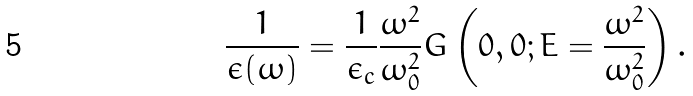Convert formula to latex. <formula><loc_0><loc_0><loc_500><loc_500>\frac { 1 } { \epsilon ( \omega ) } = \frac { 1 } { \epsilon _ { c } } \frac { \omega ^ { 2 } } { \omega _ { 0 } ^ { 2 } } G \left ( 0 , 0 ; E = \frac { \omega ^ { 2 } } { \omega _ { 0 } ^ { 2 } } \right ) .</formula> 